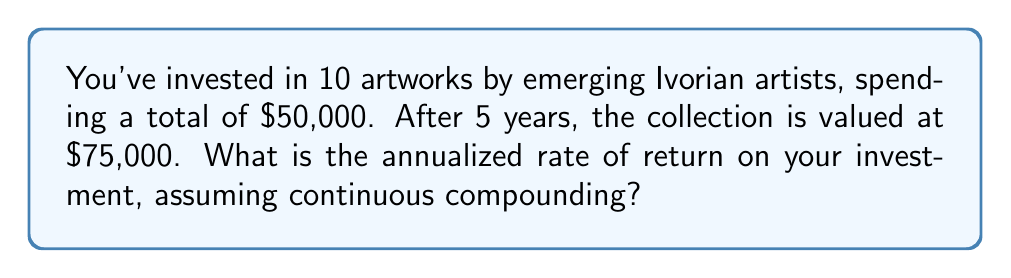Could you help me with this problem? To solve this problem, we'll use the continuous compound interest formula:

$$A = P \cdot e^{rt}$$

Where:
$A$ = Final amount
$P$ = Principal (initial investment)
$r$ = Annual rate of return
$t$ = Time in years
$e$ = Euler's number (approximately 2.71828)

We know:
$A = \$75,000$
$P = \$50,000$
$t = 5$ years

Step 1: Substitute the known values into the formula:
$$75,000 = 50,000 \cdot e^{5r}$$

Step 2: Divide both sides by 50,000:
$$\frac{75,000}{50,000} = e^{5r}$$
$$1.5 = e^{5r}$$

Step 3: Take the natural logarithm of both sides:
$$\ln(1.5) = \ln(e^{5r})$$
$$\ln(1.5) = 5r$$

Step 4: Solve for $r$:
$$r = \frac{\ln(1.5)}{5}$$

Step 5: Calculate the result:
$$r = \frac{0.4054651081081644}{5} \approx 0.0810930216$$

Step 6: Convert to a percentage:
$$0.0810930216 \times 100\% \approx 8.11\%$$
Answer: 8.11% 